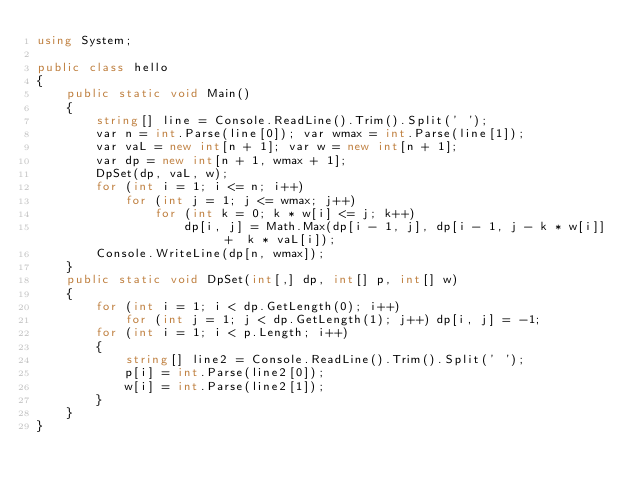Convert code to text. <code><loc_0><loc_0><loc_500><loc_500><_C#_>using System;

public class hello
{
    public static void Main()
    {
        string[] line = Console.ReadLine().Trim().Split(' ');
        var n = int.Parse(line[0]); var wmax = int.Parse(line[1]);
        var vaL = new int[n + 1]; var w = new int[n + 1];
        var dp = new int[n + 1, wmax + 1];
        DpSet(dp, vaL, w);
        for (int i = 1; i <= n; i++)
            for (int j = 1; j <= wmax; j++)
                for (int k = 0; k * w[i] <= j; k++)
                    dp[i, j] = Math.Max(dp[i - 1, j], dp[i - 1, j - k * w[i]] +  k * vaL[i]);
        Console.WriteLine(dp[n, wmax]);
    }
    public static void DpSet(int[,] dp, int[] p, int[] w)
    {
        for (int i = 1; i < dp.GetLength(0); i++)
            for (int j = 1; j < dp.GetLength(1); j++) dp[i, j] = -1;
        for (int i = 1; i < p.Length; i++)
        {
            string[] line2 = Console.ReadLine().Trim().Split(' ');
            p[i] = int.Parse(line2[0]);
            w[i] = int.Parse(line2[1]);
        }
    }
}</code> 